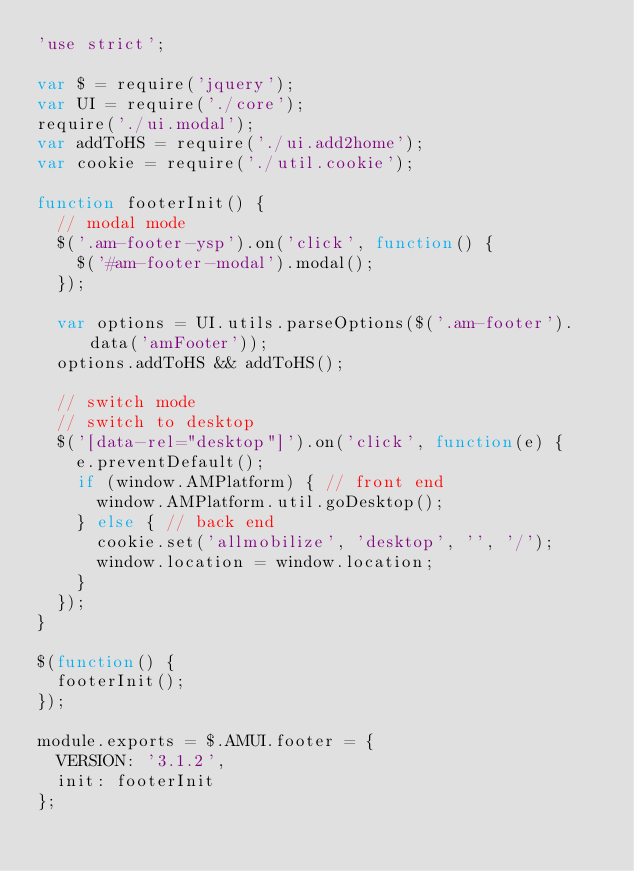Convert code to text. <code><loc_0><loc_0><loc_500><loc_500><_JavaScript_>'use strict';

var $ = require('jquery');
var UI = require('./core');
require('./ui.modal');
var addToHS = require('./ui.add2home');
var cookie = require('./util.cookie');

function footerInit() {
  // modal mode
  $('.am-footer-ysp').on('click', function() {
    $('#am-footer-modal').modal();
  });

  var options = UI.utils.parseOptions($('.am-footer').data('amFooter'));
  options.addToHS && addToHS();

  // switch mode
  // switch to desktop
  $('[data-rel="desktop"]').on('click', function(e) {
    e.preventDefault();
    if (window.AMPlatform) { // front end
      window.AMPlatform.util.goDesktop();
    } else { // back end
      cookie.set('allmobilize', 'desktop', '', '/');
      window.location = window.location;
    }
  });
}

$(function() {
  footerInit();
});

module.exports = $.AMUI.footer = {
  VERSION: '3.1.2',
  init: footerInit
};
</code> 